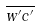Convert formula to latex. <formula><loc_0><loc_0><loc_500><loc_500>\overline { w ^ { \prime } c ^ { \prime } }</formula> 